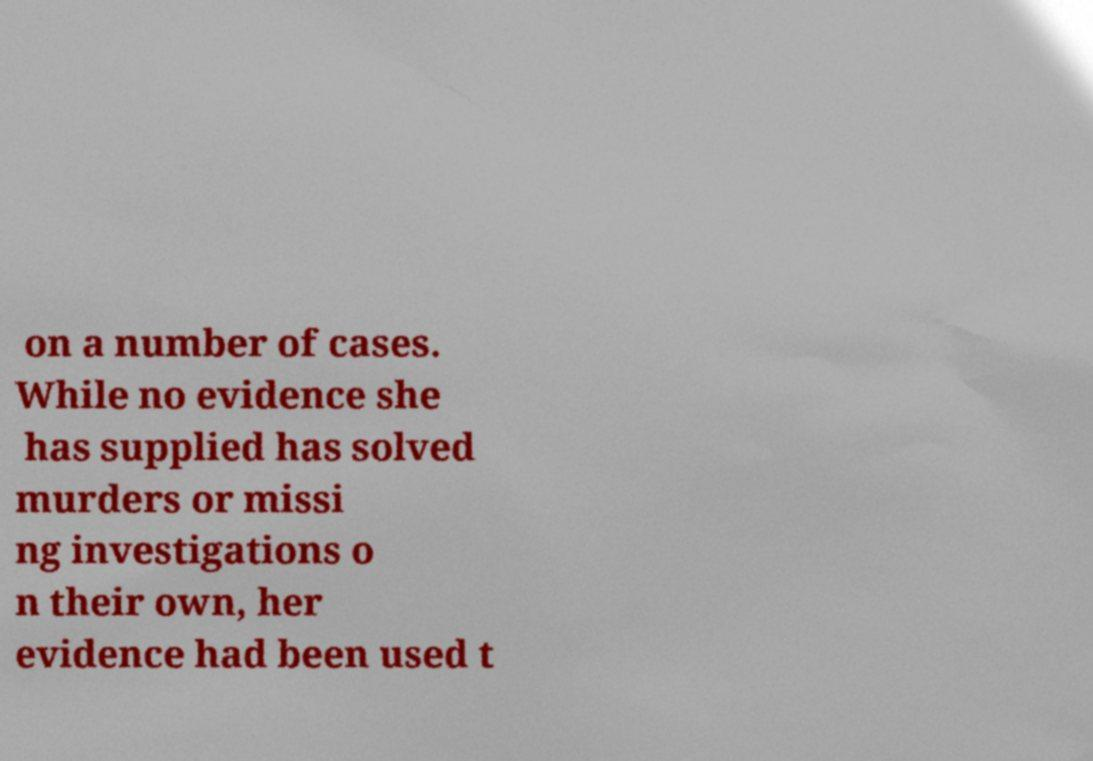Could you extract and type out the text from this image? on a number of cases. While no evidence she has supplied has solved murders or missi ng investigations o n their own, her evidence had been used t 